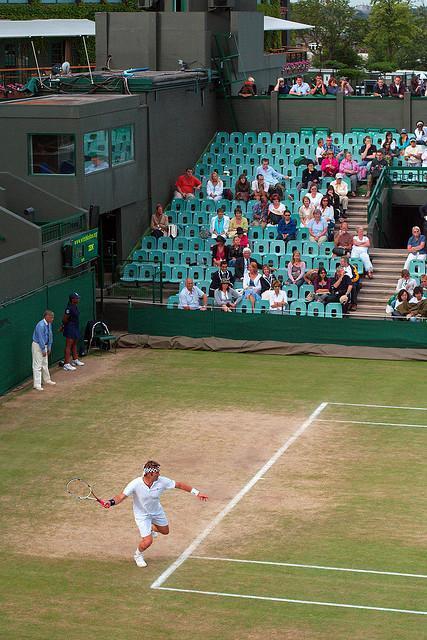How many people can be seen?
Give a very brief answer. 2. 